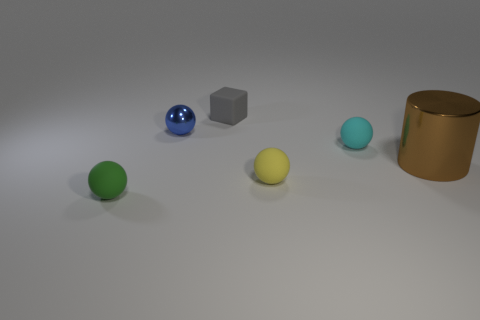There is a blue thing that is the same size as the yellow matte object; what is its shape?
Keep it short and to the point. Sphere. What number of things are things that are behind the small yellow ball or rubber spheres to the right of the gray object?
Provide a short and direct response. 5. There is a green thing that is the same size as the blue shiny thing; what material is it?
Make the answer very short. Rubber. How many other objects are there of the same material as the green ball?
Keep it short and to the point. 3. Are there an equal number of green things right of the tiny metal thing and tiny rubber blocks in front of the small yellow ball?
Keep it short and to the point. Yes. How many gray objects are big shiny things or shiny balls?
Your answer should be compact. 0. There is a big metallic thing; is it the same color as the metal object behind the cyan rubber thing?
Your answer should be compact. No. How many other objects are there of the same color as the small matte block?
Offer a very short reply. 0. Is the number of small gray matte objects less than the number of tiny red matte spheres?
Offer a very short reply. No. How many tiny yellow things are in front of the green ball that is in front of the matte sphere behind the brown cylinder?
Make the answer very short. 0. 